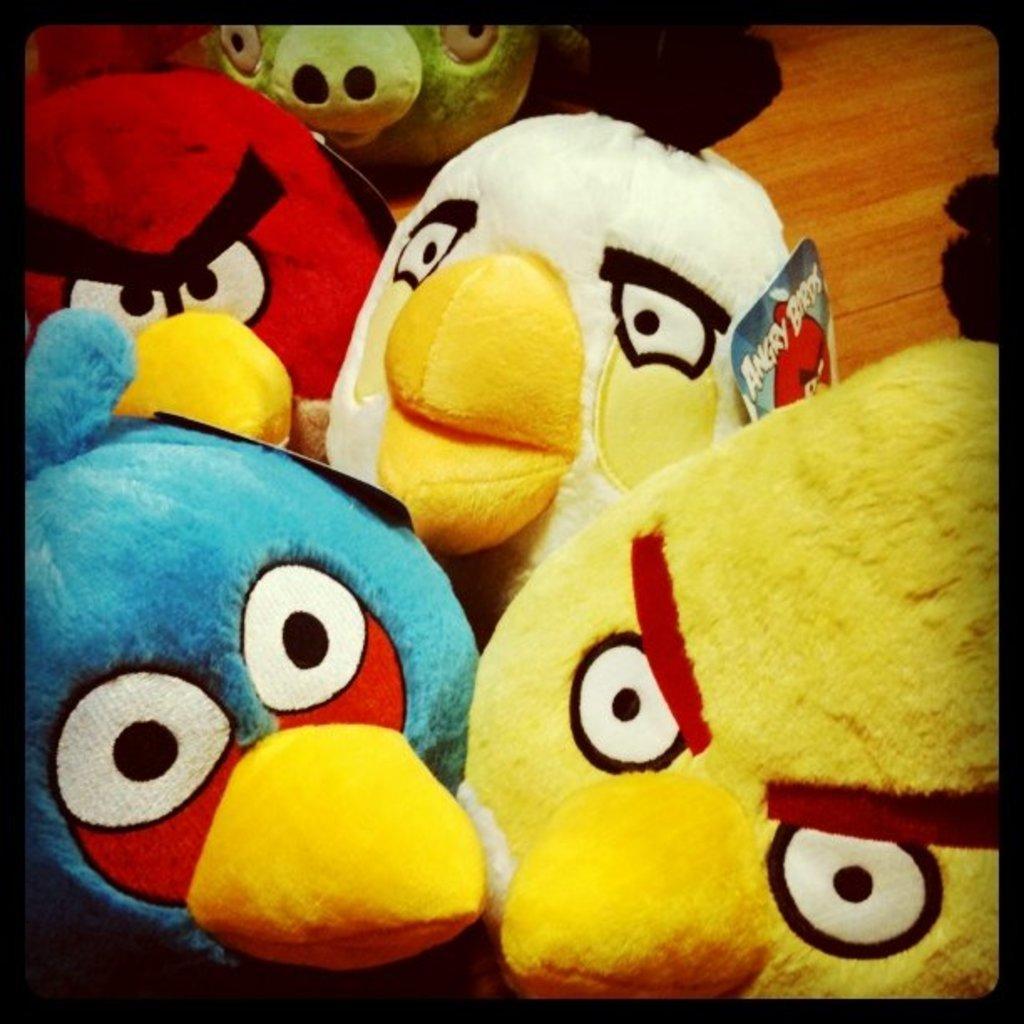How would you summarize this image in a sentence or two? In this image there are angry birds toys with tags on the wooden floor. 